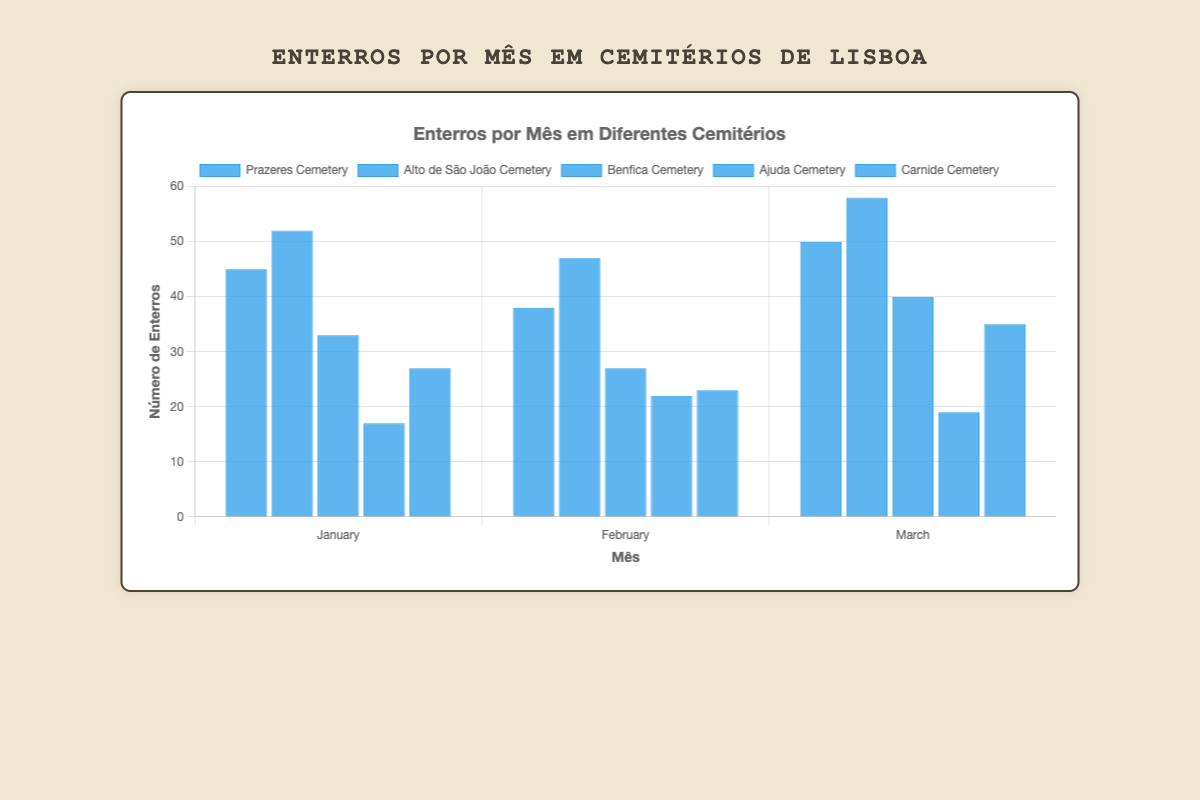Which cemetery had the highest number of burials in January? In January, the highest bar in the chart corresponds to Alto de São João Cemetery, indicating it had the highest number of burials.
Answer: Alto de São João Cemetery Which month had the highest number of burials in Prazeres Cemetery? For Prazeres Cemetery, the bar representing March is the tallest, indicating it had the highest number of burials in that month.
Answer: March Compare the number of burials in Benfica Cemetery and Carnide Cemetery in February. Which one had more? In February, comparing the heights of the bars for Benfica Cemetery and Carnide Cemetery, Benfica Cemetery had fewer (27) than Carnide Cemetery (23).
Answer: Benfica Cemetery What is the average number of burials in Alto de São João Cemetery over the three months? The sum of the burials is 52 in January, 47 in February, and 58 in March, totaling 157. Dividing this by 3 months gives an average of 157/3 = 52.33.
Answer: 52.33 How many more burials were there in March compared to February in Ajuda Cemetery? In Ajuda Cemetery, there were 22 burials in February and 19 in March. The difference is 22 - 19 = 3.
Answer: 3 Which cemetery had the least number of burials in any month, and what was that number? The bar for Ajuda Cemetery in January is the shortest, representing the smallest number of burials, which is 17.
Answer: Ajuda Cemetery, 17 Sum up the number of burials in Carnide Cemetery for all the months shown. The number of burials in Carnide Cemetery is 27 in January, 23 in February, and 35 in March. Summing them up gives 27 + 23 + 35 = 85.
Answer: 85 Is March generally a month with more burials compared to January for all cemeteries? By comparing the heights of the bars for March and January in each cemetery, March has more burials in Prazeres, Alto de São João, Benfica, and Carnide Cemeteries. Only Ajuda Cemetery had fewer burials in March. Thus, generally, March had more.
Answer: Yes 